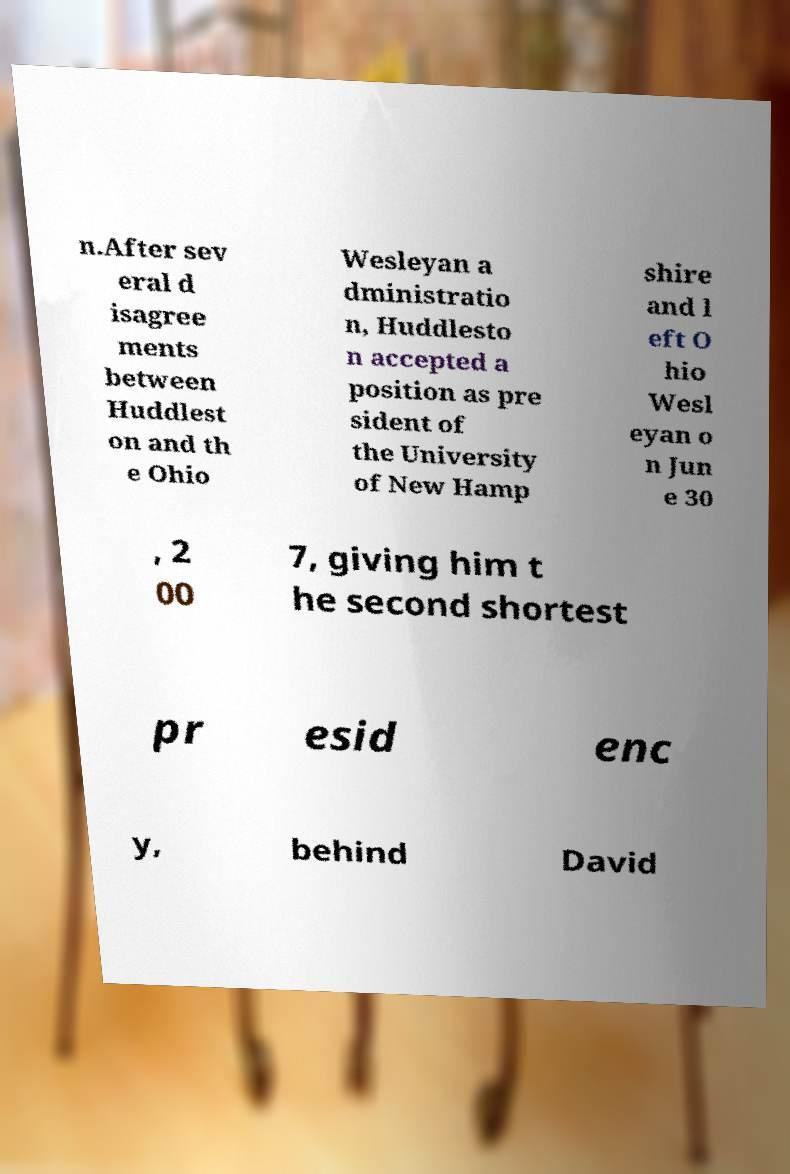Please identify and transcribe the text found in this image. n.After sev eral d isagree ments between Huddlest on and th e Ohio Wesleyan a dministratio n, Huddlesto n accepted a position as pre sident of the University of New Hamp shire and l eft O hio Wesl eyan o n Jun e 30 , 2 00 7, giving him t he second shortest pr esid enc y, behind David 